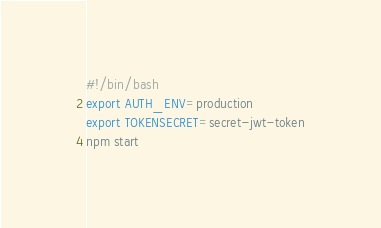<code> <loc_0><loc_0><loc_500><loc_500><_Bash_>#!/bin/bash
export AUTH_ENV=production
export TOKENSECRET=secret-jwt-token
npm start
</code> 